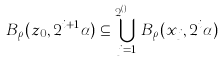<formula> <loc_0><loc_0><loc_500><loc_500>B _ { \rho } ( z _ { 0 } , 2 ^ { i + 1 } \alpha ) \subseteq \bigcup ^ { 2 ^ { { d } ( E ) } } _ { j = 1 } B _ { \rho } ( x _ { j } , 2 ^ { i } \alpha )</formula> 